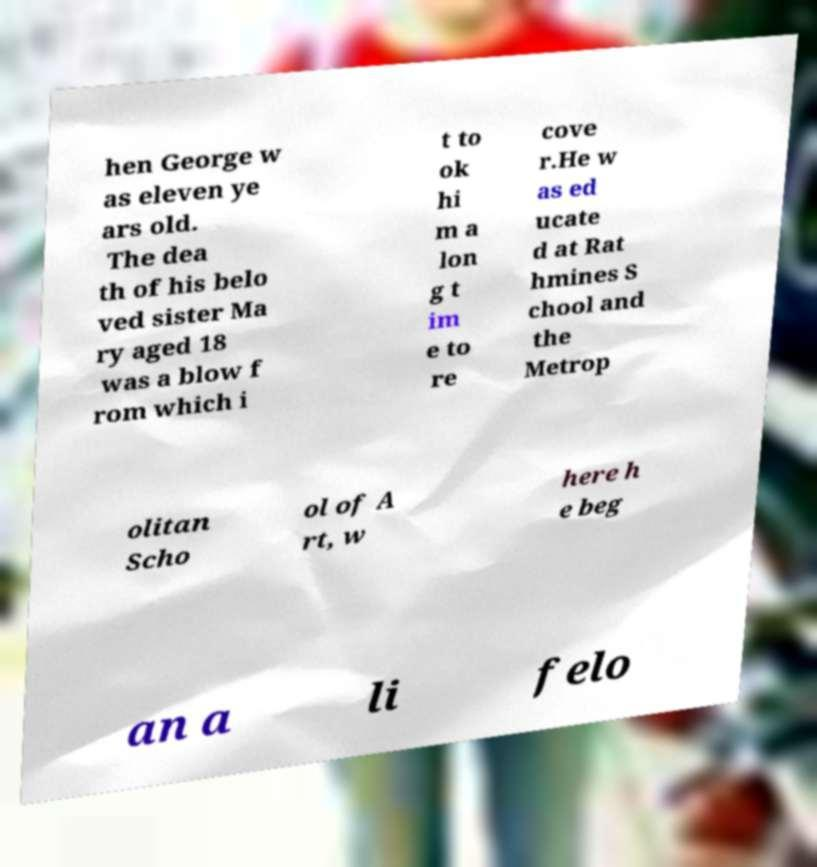There's text embedded in this image that I need extracted. Can you transcribe it verbatim? hen George w as eleven ye ars old. The dea th of his belo ved sister Ma ry aged 18 was a blow f rom which i t to ok hi m a lon g t im e to re cove r.He w as ed ucate d at Rat hmines S chool and the Metrop olitan Scho ol of A rt, w here h e beg an a li felo 